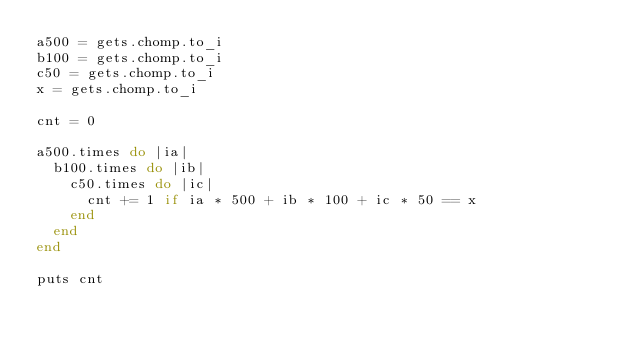<code> <loc_0><loc_0><loc_500><loc_500><_Ruby_>a500 = gets.chomp.to_i
b100 = gets.chomp.to_i
c50 = gets.chomp.to_i
x = gets.chomp.to_i

cnt = 0

a500.times do |ia|
  b100.times do |ib|
    c50.times do |ic|
      cnt += 1 if ia * 500 + ib * 100 + ic * 50 == x
    end
  end
end

puts cnt
</code> 